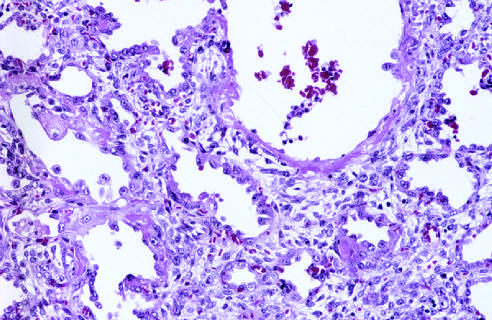re bite cells similar to the one in this smear seen at this stage, associated with regeneration and repair?
Answer the question using a single word or phrase. No 